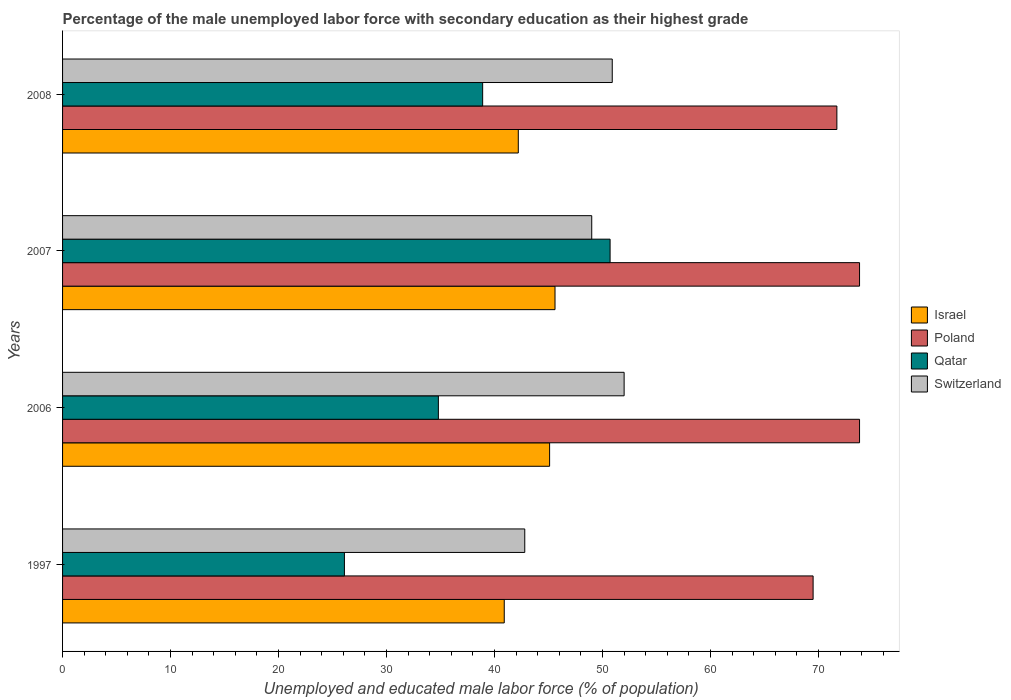How many different coloured bars are there?
Give a very brief answer. 4. How many groups of bars are there?
Offer a very short reply. 4. Are the number of bars on each tick of the Y-axis equal?
Your answer should be compact. Yes. What is the label of the 2nd group of bars from the top?
Your answer should be very brief. 2007. What is the percentage of the unemployed male labor force with secondary education in Poland in 1997?
Your answer should be compact. 69.5. Across all years, what is the maximum percentage of the unemployed male labor force with secondary education in Qatar?
Keep it short and to the point. 50.7. Across all years, what is the minimum percentage of the unemployed male labor force with secondary education in Poland?
Provide a short and direct response. 69.5. In which year was the percentage of the unemployed male labor force with secondary education in Israel maximum?
Your answer should be very brief. 2007. In which year was the percentage of the unemployed male labor force with secondary education in Switzerland minimum?
Provide a short and direct response. 1997. What is the total percentage of the unemployed male labor force with secondary education in Qatar in the graph?
Give a very brief answer. 150.5. What is the difference between the percentage of the unemployed male labor force with secondary education in Qatar in 2007 and that in 2008?
Keep it short and to the point. 11.8. What is the difference between the percentage of the unemployed male labor force with secondary education in Qatar in 2006 and the percentage of the unemployed male labor force with secondary education in Israel in 2008?
Give a very brief answer. -7.4. What is the average percentage of the unemployed male labor force with secondary education in Qatar per year?
Give a very brief answer. 37.63. In the year 1997, what is the difference between the percentage of the unemployed male labor force with secondary education in Switzerland and percentage of the unemployed male labor force with secondary education in Qatar?
Ensure brevity in your answer.  16.7. In how many years, is the percentage of the unemployed male labor force with secondary education in Qatar greater than 30 %?
Your response must be concise. 3. What is the ratio of the percentage of the unemployed male labor force with secondary education in Qatar in 2006 to that in 2007?
Provide a short and direct response. 0.69. Is the percentage of the unemployed male labor force with secondary education in Qatar in 2006 less than that in 2007?
Your response must be concise. Yes. What is the difference between the highest and the second highest percentage of the unemployed male labor force with secondary education in Qatar?
Offer a terse response. 11.8. What is the difference between the highest and the lowest percentage of the unemployed male labor force with secondary education in Qatar?
Your response must be concise. 24.6. What does the 2nd bar from the top in 2007 represents?
Give a very brief answer. Qatar. What does the 1st bar from the bottom in 2006 represents?
Your answer should be compact. Israel. How many bars are there?
Ensure brevity in your answer.  16. Does the graph contain any zero values?
Make the answer very short. No. Where does the legend appear in the graph?
Your response must be concise. Center right. How are the legend labels stacked?
Ensure brevity in your answer.  Vertical. What is the title of the graph?
Give a very brief answer. Percentage of the male unemployed labor force with secondary education as their highest grade. Does "Caribbean small states" appear as one of the legend labels in the graph?
Make the answer very short. No. What is the label or title of the X-axis?
Your response must be concise. Unemployed and educated male labor force (% of population). What is the Unemployed and educated male labor force (% of population) in Israel in 1997?
Offer a terse response. 40.9. What is the Unemployed and educated male labor force (% of population) of Poland in 1997?
Give a very brief answer. 69.5. What is the Unemployed and educated male labor force (% of population) of Qatar in 1997?
Offer a very short reply. 26.1. What is the Unemployed and educated male labor force (% of population) of Switzerland in 1997?
Provide a short and direct response. 42.8. What is the Unemployed and educated male labor force (% of population) of Israel in 2006?
Ensure brevity in your answer.  45.1. What is the Unemployed and educated male labor force (% of population) in Poland in 2006?
Make the answer very short. 73.8. What is the Unemployed and educated male labor force (% of population) of Qatar in 2006?
Offer a very short reply. 34.8. What is the Unemployed and educated male labor force (% of population) of Switzerland in 2006?
Offer a terse response. 52. What is the Unemployed and educated male labor force (% of population) in Israel in 2007?
Provide a succinct answer. 45.6. What is the Unemployed and educated male labor force (% of population) of Poland in 2007?
Provide a succinct answer. 73.8. What is the Unemployed and educated male labor force (% of population) in Qatar in 2007?
Make the answer very short. 50.7. What is the Unemployed and educated male labor force (% of population) in Israel in 2008?
Make the answer very short. 42.2. What is the Unemployed and educated male labor force (% of population) in Poland in 2008?
Your answer should be compact. 71.7. What is the Unemployed and educated male labor force (% of population) in Qatar in 2008?
Keep it short and to the point. 38.9. What is the Unemployed and educated male labor force (% of population) in Switzerland in 2008?
Give a very brief answer. 50.9. Across all years, what is the maximum Unemployed and educated male labor force (% of population) of Israel?
Offer a terse response. 45.6. Across all years, what is the maximum Unemployed and educated male labor force (% of population) of Poland?
Provide a short and direct response. 73.8. Across all years, what is the maximum Unemployed and educated male labor force (% of population) of Qatar?
Provide a succinct answer. 50.7. Across all years, what is the minimum Unemployed and educated male labor force (% of population) of Israel?
Provide a short and direct response. 40.9. Across all years, what is the minimum Unemployed and educated male labor force (% of population) of Poland?
Make the answer very short. 69.5. Across all years, what is the minimum Unemployed and educated male labor force (% of population) of Qatar?
Your answer should be very brief. 26.1. Across all years, what is the minimum Unemployed and educated male labor force (% of population) of Switzerland?
Keep it short and to the point. 42.8. What is the total Unemployed and educated male labor force (% of population) in Israel in the graph?
Make the answer very short. 173.8. What is the total Unemployed and educated male labor force (% of population) in Poland in the graph?
Provide a short and direct response. 288.8. What is the total Unemployed and educated male labor force (% of population) in Qatar in the graph?
Your answer should be very brief. 150.5. What is the total Unemployed and educated male labor force (% of population) in Switzerland in the graph?
Offer a terse response. 194.7. What is the difference between the Unemployed and educated male labor force (% of population) of Israel in 1997 and that in 2006?
Keep it short and to the point. -4.2. What is the difference between the Unemployed and educated male labor force (% of population) in Qatar in 1997 and that in 2006?
Keep it short and to the point. -8.7. What is the difference between the Unemployed and educated male labor force (% of population) of Qatar in 1997 and that in 2007?
Ensure brevity in your answer.  -24.6. What is the difference between the Unemployed and educated male labor force (% of population) in Switzerland in 1997 and that in 2007?
Provide a succinct answer. -6.2. What is the difference between the Unemployed and educated male labor force (% of population) in Qatar in 1997 and that in 2008?
Your answer should be very brief. -12.8. What is the difference between the Unemployed and educated male labor force (% of population) in Switzerland in 1997 and that in 2008?
Make the answer very short. -8.1. What is the difference between the Unemployed and educated male labor force (% of population) in Israel in 2006 and that in 2007?
Ensure brevity in your answer.  -0.5. What is the difference between the Unemployed and educated male labor force (% of population) in Poland in 2006 and that in 2007?
Give a very brief answer. 0. What is the difference between the Unemployed and educated male labor force (% of population) of Qatar in 2006 and that in 2007?
Provide a succinct answer. -15.9. What is the difference between the Unemployed and educated male labor force (% of population) in Poland in 2006 and that in 2008?
Offer a terse response. 2.1. What is the difference between the Unemployed and educated male labor force (% of population) of Switzerland in 2006 and that in 2008?
Provide a short and direct response. 1.1. What is the difference between the Unemployed and educated male labor force (% of population) in Israel in 1997 and the Unemployed and educated male labor force (% of population) in Poland in 2006?
Your answer should be compact. -32.9. What is the difference between the Unemployed and educated male labor force (% of population) of Israel in 1997 and the Unemployed and educated male labor force (% of population) of Qatar in 2006?
Ensure brevity in your answer.  6.1. What is the difference between the Unemployed and educated male labor force (% of population) of Poland in 1997 and the Unemployed and educated male labor force (% of population) of Qatar in 2006?
Provide a short and direct response. 34.7. What is the difference between the Unemployed and educated male labor force (% of population) of Qatar in 1997 and the Unemployed and educated male labor force (% of population) of Switzerland in 2006?
Ensure brevity in your answer.  -25.9. What is the difference between the Unemployed and educated male labor force (% of population) of Israel in 1997 and the Unemployed and educated male labor force (% of population) of Poland in 2007?
Keep it short and to the point. -32.9. What is the difference between the Unemployed and educated male labor force (% of population) of Poland in 1997 and the Unemployed and educated male labor force (% of population) of Qatar in 2007?
Your response must be concise. 18.8. What is the difference between the Unemployed and educated male labor force (% of population) of Qatar in 1997 and the Unemployed and educated male labor force (% of population) of Switzerland in 2007?
Your answer should be very brief. -22.9. What is the difference between the Unemployed and educated male labor force (% of population) of Israel in 1997 and the Unemployed and educated male labor force (% of population) of Poland in 2008?
Your answer should be compact. -30.8. What is the difference between the Unemployed and educated male labor force (% of population) of Poland in 1997 and the Unemployed and educated male labor force (% of population) of Qatar in 2008?
Provide a short and direct response. 30.6. What is the difference between the Unemployed and educated male labor force (% of population) of Qatar in 1997 and the Unemployed and educated male labor force (% of population) of Switzerland in 2008?
Offer a terse response. -24.8. What is the difference between the Unemployed and educated male labor force (% of population) in Israel in 2006 and the Unemployed and educated male labor force (% of population) in Poland in 2007?
Provide a short and direct response. -28.7. What is the difference between the Unemployed and educated male labor force (% of population) of Israel in 2006 and the Unemployed and educated male labor force (% of population) of Switzerland in 2007?
Your answer should be compact. -3.9. What is the difference between the Unemployed and educated male labor force (% of population) of Poland in 2006 and the Unemployed and educated male labor force (% of population) of Qatar in 2007?
Make the answer very short. 23.1. What is the difference between the Unemployed and educated male labor force (% of population) in Poland in 2006 and the Unemployed and educated male labor force (% of population) in Switzerland in 2007?
Your response must be concise. 24.8. What is the difference between the Unemployed and educated male labor force (% of population) in Qatar in 2006 and the Unemployed and educated male labor force (% of population) in Switzerland in 2007?
Ensure brevity in your answer.  -14.2. What is the difference between the Unemployed and educated male labor force (% of population) in Israel in 2006 and the Unemployed and educated male labor force (% of population) in Poland in 2008?
Provide a succinct answer. -26.6. What is the difference between the Unemployed and educated male labor force (% of population) in Poland in 2006 and the Unemployed and educated male labor force (% of population) in Qatar in 2008?
Keep it short and to the point. 34.9. What is the difference between the Unemployed and educated male labor force (% of population) in Poland in 2006 and the Unemployed and educated male labor force (% of population) in Switzerland in 2008?
Ensure brevity in your answer.  22.9. What is the difference between the Unemployed and educated male labor force (% of population) of Qatar in 2006 and the Unemployed and educated male labor force (% of population) of Switzerland in 2008?
Ensure brevity in your answer.  -16.1. What is the difference between the Unemployed and educated male labor force (% of population) of Israel in 2007 and the Unemployed and educated male labor force (% of population) of Poland in 2008?
Give a very brief answer. -26.1. What is the difference between the Unemployed and educated male labor force (% of population) in Israel in 2007 and the Unemployed and educated male labor force (% of population) in Switzerland in 2008?
Give a very brief answer. -5.3. What is the difference between the Unemployed and educated male labor force (% of population) of Poland in 2007 and the Unemployed and educated male labor force (% of population) of Qatar in 2008?
Your response must be concise. 34.9. What is the difference between the Unemployed and educated male labor force (% of population) in Poland in 2007 and the Unemployed and educated male labor force (% of population) in Switzerland in 2008?
Give a very brief answer. 22.9. What is the average Unemployed and educated male labor force (% of population) of Israel per year?
Offer a very short reply. 43.45. What is the average Unemployed and educated male labor force (% of population) of Poland per year?
Provide a succinct answer. 72.2. What is the average Unemployed and educated male labor force (% of population) of Qatar per year?
Provide a short and direct response. 37.62. What is the average Unemployed and educated male labor force (% of population) of Switzerland per year?
Your response must be concise. 48.67. In the year 1997, what is the difference between the Unemployed and educated male labor force (% of population) in Israel and Unemployed and educated male labor force (% of population) in Poland?
Provide a short and direct response. -28.6. In the year 1997, what is the difference between the Unemployed and educated male labor force (% of population) in Israel and Unemployed and educated male labor force (% of population) in Qatar?
Keep it short and to the point. 14.8. In the year 1997, what is the difference between the Unemployed and educated male labor force (% of population) of Israel and Unemployed and educated male labor force (% of population) of Switzerland?
Provide a succinct answer. -1.9. In the year 1997, what is the difference between the Unemployed and educated male labor force (% of population) in Poland and Unemployed and educated male labor force (% of population) in Qatar?
Provide a short and direct response. 43.4. In the year 1997, what is the difference between the Unemployed and educated male labor force (% of population) of Poland and Unemployed and educated male labor force (% of population) of Switzerland?
Give a very brief answer. 26.7. In the year 1997, what is the difference between the Unemployed and educated male labor force (% of population) of Qatar and Unemployed and educated male labor force (% of population) of Switzerland?
Provide a succinct answer. -16.7. In the year 2006, what is the difference between the Unemployed and educated male labor force (% of population) of Israel and Unemployed and educated male labor force (% of population) of Poland?
Give a very brief answer. -28.7. In the year 2006, what is the difference between the Unemployed and educated male labor force (% of population) in Israel and Unemployed and educated male labor force (% of population) in Qatar?
Make the answer very short. 10.3. In the year 2006, what is the difference between the Unemployed and educated male labor force (% of population) of Israel and Unemployed and educated male labor force (% of population) of Switzerland?
Give a very brief answer. -6.9. In the year 2006, what is the difference between the Unemployed and educated male labor force (% of population) of Poland and Unemployed and educated male labor force (% of population) of Qatar?
Your response must be concise. 39. In the year 2006, what is the difference between the Unemployed and educated male labor force (% of population) in Poland and Unemployed and educated male labor force (% of population) in Switzerland?
Offer a very short reply. 21.8. In the year 2006, what is the difference between the Unemployed and educated male labor force (% of population) of Qatar and Unemployed and educated male labor force (% of population) of Switzerland?
Your response must be concise. -17.2. In the year 2007, what is the difference between the Unemployed and educated male labor force (% of population) of Israel and Unemployed and educated male labor force (% of population) of Poland?
Give a very brief answer. -28.2. In the year 2007, what is the difference between the Unemployed and educated male labor force (% of population) in Israel and Unemployed and educated male labor force (% of population) in Qatar?
Your answer should be compact. -5.1. In the year 2007, what is the difference between the Unemployed and educated male labor force (% of population) in Israel and Unemployed and educated male labor force (% of population) in Switzerland?
Your answer should be very brief. -3.4. In the year 2007, what is the difference between the Unemployed and educated male labor force (% of population) in Poland and Unemployed and educated male labor force (% of population) in Qatar?
Provide a succinct answer. 23.1. In the year 2007, what is the difference between the Unemployed and educated male labor force (% of population) in Poland and Unemployed and educated male labor force (% of population) in Switzerland?
Your response must be concise. 24.8. In the year 2007, what is the difference between the Unemployed and educated male labor force (% of population) in Qatar and Unemployed and educated male labor force (% of population) in Switzerland?
Your answer should be compact. 1.7. In the year 2008, what is the difference between the Unemployed and educated male labor force (% of population) in Israel and Unemployed and educated male labor force (% of population) in Poland?
Your response must be concise. -29.5. In the year 2008, what is the difference between the Unemployed and educated male labor force (% of population) of Poland and Unemployed and educated male labor force (% of population) of Qatar?
Offer a very short reply. 32.8. In the year 2008, what is the difference between the Unemployed and educated male labor force (% of population) of Poland and Unemployed and educated male labor force (% of population) of Switzerland?
Your answer should be compact. 20.8. In the year 2008, what is the difference between the Unemployed and educated male labor force (% of population) of Qatar and Unemployed and educated male labor force (% of population) of Switzerland?
Offer a very short reply. -12. What is the ratio of the Unemployed and educated male labor force (% of population) of Israel in 1997 to that in 2006?
Offer a terse response. 0.91. What is the ratio of the Unemployed and educated male labor force (% of population) of Poland in 1997 to that in 2006?
Offer a very short reply. 0.94. What is the ratio of the Unemployed and educated male labor force (% of population) of Switzerland in 1997 to that in 2006?
Offer a terse response. 0.82. What is the ratio of the Unemployed and educated male labor force (% of population) in Israel in 1997 to that in 2007?
Provide a succinct answer. 0.9. What is the ratio of the Unemployed and educated male labor force (% of population) in Poland in 1997 to that in 2007?
Give a very brief answer. 0.94. What is the ratio of the Unemployed and educated male labor force (% of population) in Qatar in 1997 to that in 2007?
Provide a short and direct response. 0.51. What is the ratio of the Unemployed and educated male labor force (% of population) of Switzerland in 1997 to that in 2007?
Your answer should be very brief. 0.87. What is the ratio of the Unemployed and educated male labor force (% of population) of Israel in 1997 to that in 2008?
Make the answer very short. 0.97. What is the ratio of the Unemployed and educated male labor force (% of population) of Poland in 1997 to that in 2008?
Give a very brief answer. 0.97. What is the ratio of the Unemployed and educated male labor force (% of population) in Qatar in 1997 to that in 2008?
Provide a short and direct response. 0.67. What is the ratio of the Unemployed and educated male labor force (% of population) of Switzerland in 1997 to that in 2008?
Provide a succinct answer. 0.84. What is the ratio of the Unemployed and educated male labor force (% of population) of Qatar in 2006 to that in 2007?
Provide a short and direct response. 0.69. What is the ratio of the Unemployed and educated male labor force (% of population) in Switzerland in 2006 to that in 2007?
Your response must be concise. 1.06. What is the ratio of the Unemployed and educated male labor force (% of population) in Israel in 2006 to that in 2008?
Make the answer very short. 1.07. What is the ratio of the Unemployed and educated male labor force (% of population) in Poland in 2006 to that in 2008?
Your answer should be very brief. 1.03. What is the ratio of the Unemployed and educated male labor force (% of population) of Qatar in 2006 to that in 2008?
Make the answer very short. 0.89. What is the ratio of the Unemployed and educated male labor force (% of population) in Switzerland in 2006 to that in 2008?
Keep it short and to the point. 1.02. What is the ratio of the Unemployed and educated male labor force (% of population) of Israel in 2007 to that in 2008?
Provide a succinct answer. 1.08. What is the ratio of the Unemployed and educated male labor force (% of population) of Poland in 2007 to that in 2008?
Give a very brief answer. 1.03. What is the ratio of the Unemployed and educated male labor force (% of population) of Qatar in 2007 to that in 2008?
Provide a succinct answer. 1.3. What is the ratio of the Unemployed and educated male labor force (% of population) of Switzerland in 2007 to that in 2008?
Make the answer very short. 0.96. What is the difference between the highest and the lowest Unemployed and educated male labor force (% of population) of Israel?
Keep it short and to the point. 4.7. What is the difference between the highest and the lowest Unemployed and educated male labor force (% of population) of Qatar?
Keep it short and to the point. 24.6. 